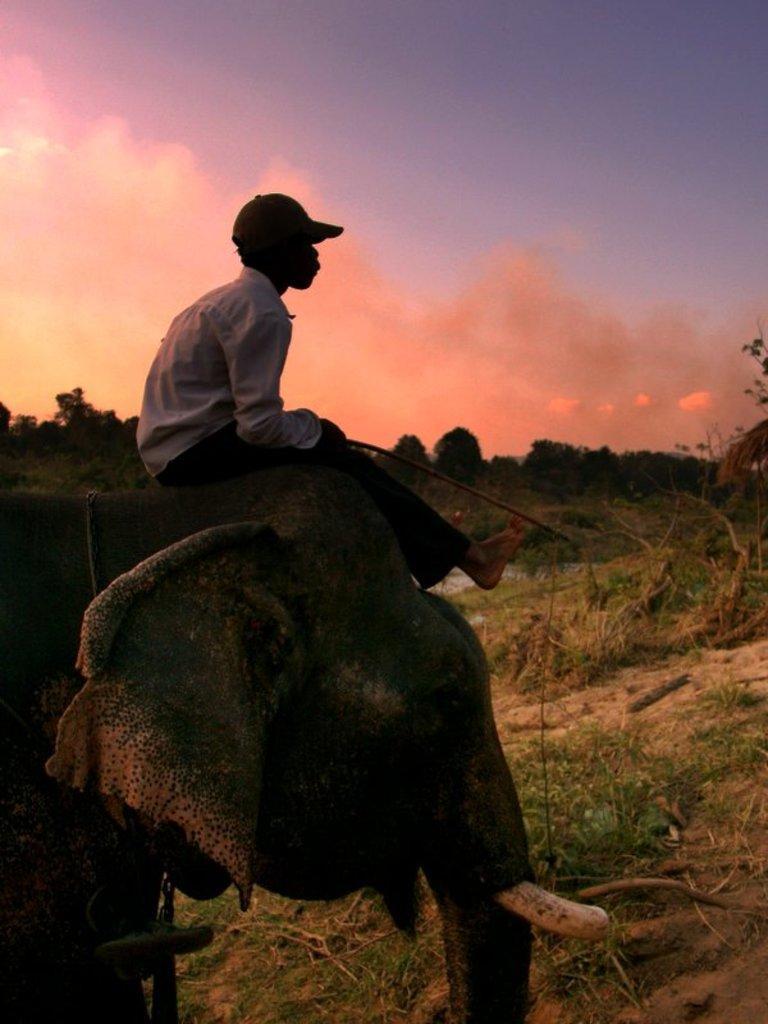Please provide a concise description of this image. This picture shows a man seated on an Elephant head and we see few trees around and a cloudy Sky 